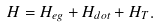<formula> <loc_0><loc_0><loc_500><loc_500>H = H _ { e g } + H _ { d o t } + H _ { T } .</formula> 